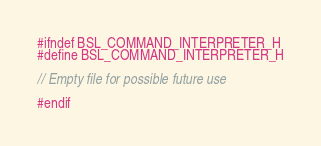<code> <loc_0><loc_0><loc_500><loc_500><_C_>#ifndef BSL_COMMAND_INTERPRETER_H
#define BSL_COMMAND_INTERPRETER_H

// Empty file for possible future use

#endif

</code> 